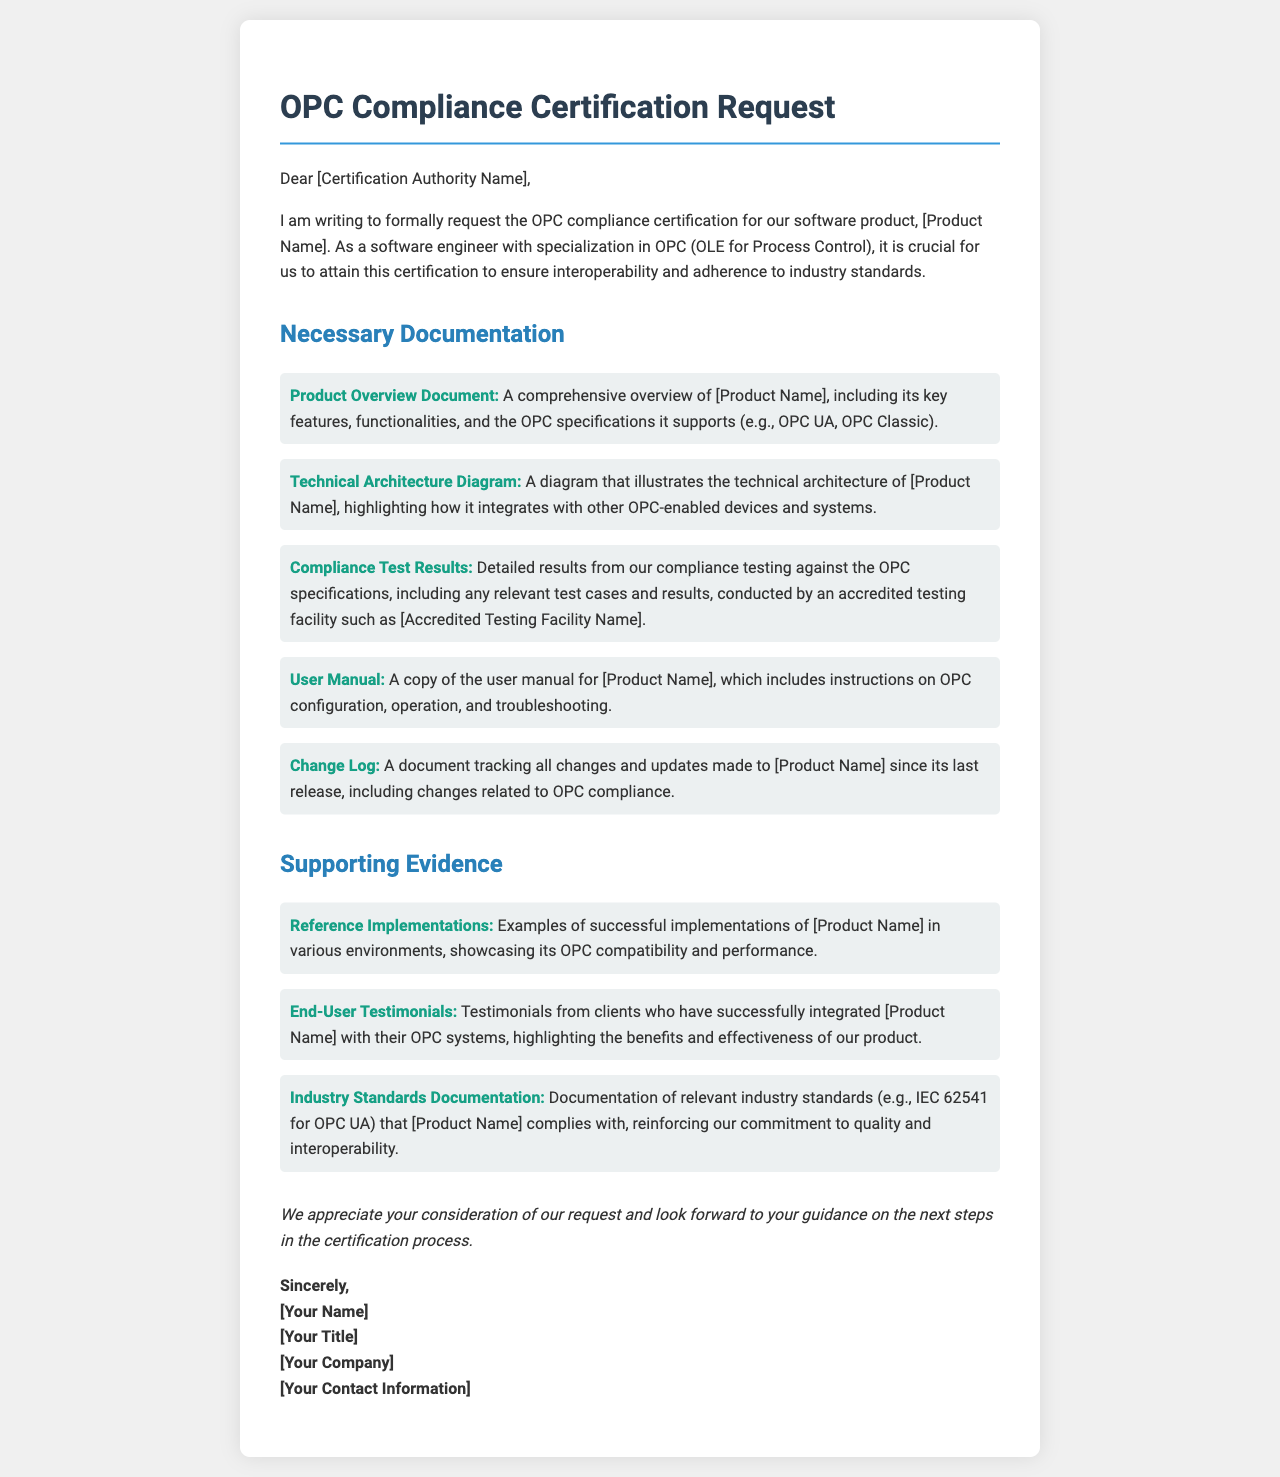What is the name of the document? The document is titled as "OPC Compliance Certification Request".
Answer: OPC Compliance Certification Request Who is the intended recipient of the letter? The recipient is addressed as "[Certification Authority Name]".
Answer: [Certification Authority Name] What is the purpose of the letter? The purpose of the letter is to request OPC compliance certification for a software product.
Answer: Request OPC compliance certification What is one of the necessary documentation items listed? The document lists multiple items; for example, "Product Overview Document".
Answer: Product Overview Document Who conducted the compliance testing? The letter mentions that testing is conducted by an "accredited testing facility".
Answer: Accredited testing facility What type of evidence is requested to support the certification? The letter requests "End-User Testimonials" as one type of supporting evidence.
Answer: End-User Testimonials What is mentioned as an example of industry standards documentation? The letter references "IEC 62541 for OPC UA".
Answer: IEC 62541 for OPC UA What is the closing sentiment of the letter? The letter expresses appreciation for the consideration of the request.
Answer: Appreciation of consideration What is the sign-off of the letter? The letter closes with "Sincerely," followed by the sender's name and details.
Answer: Sincerely, 